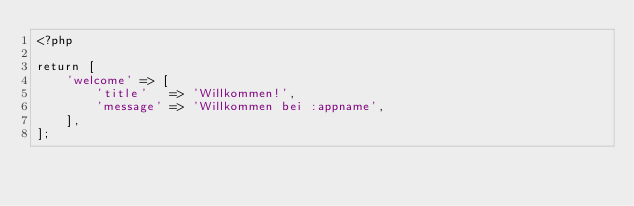Convert code to text. <code><loc_0><loc_0><loc_500><loc_500><_PHP_><?php

return [
    'welcome' => [
        'title'   => 'Willkommen!',
        'message' => 'Willkommen bei :appname',
    ],
];
</code> 